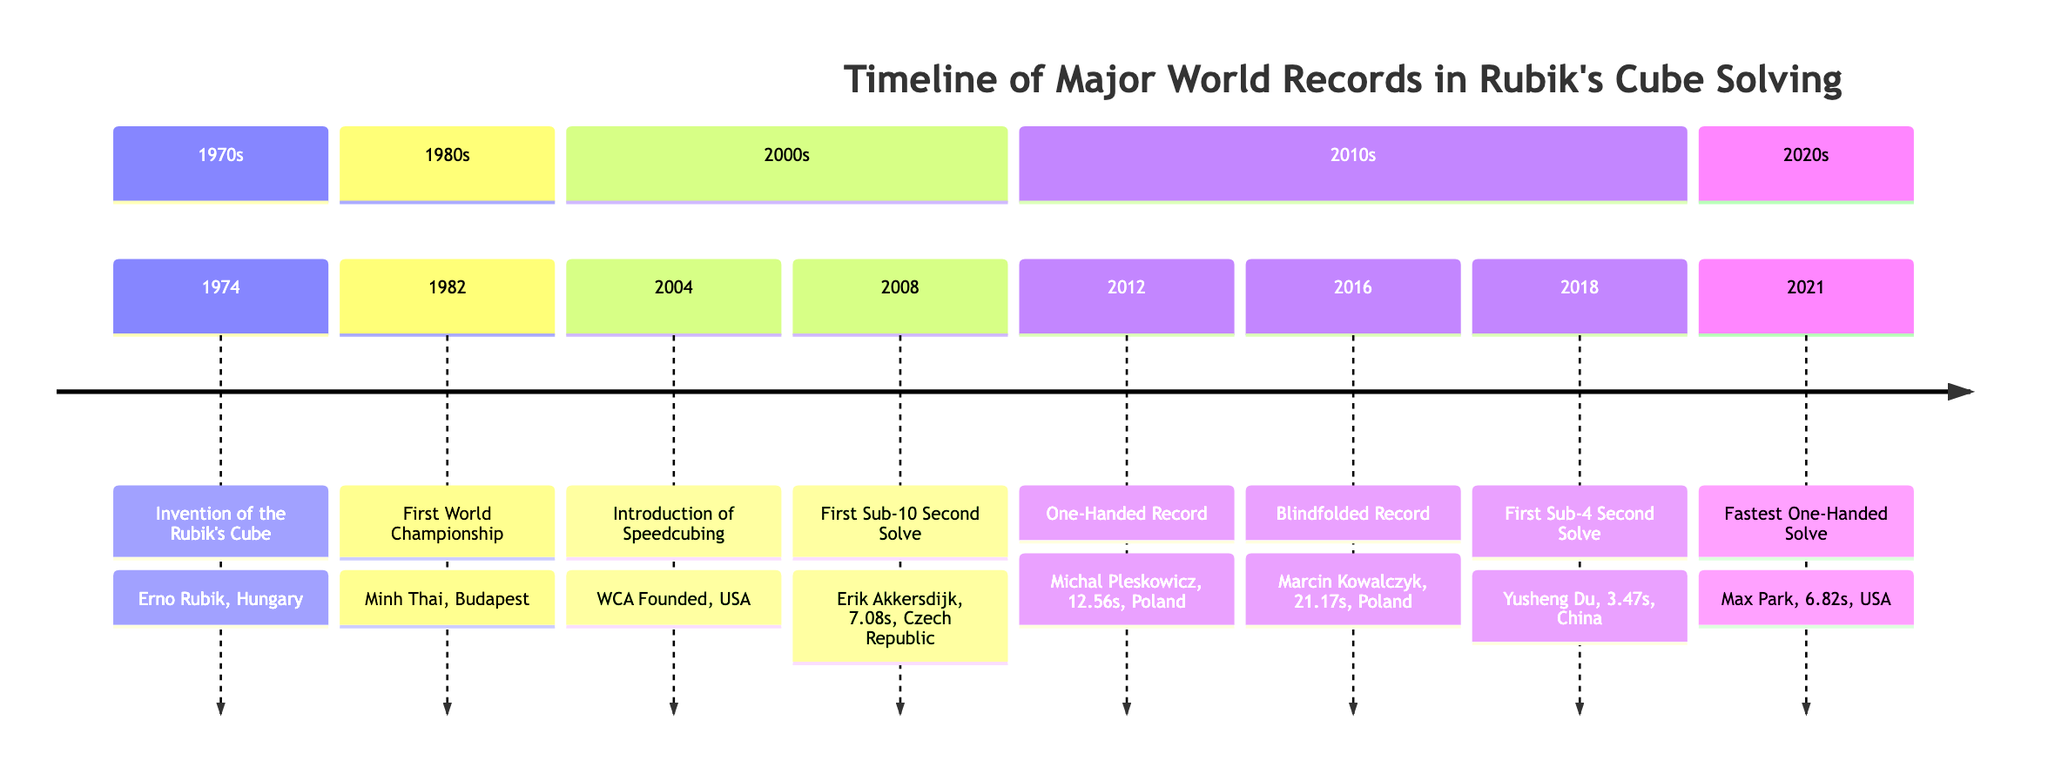What year was the Rubik's Cube invented? The diagram shows that the Rubik's Cube was invented in 1974, as indicated in the 1970s section.
Answer: 1974 Who set the first blindfolded record? Looking at the timeline, the blindfolded record was set by Marcin Kowalczyk in 2016.
Answer: Marcin Kowalczyk What was the fastest one-handed solve time? The fastest one-handed solve time is recorded as 6.82 seconds in 2021 by Max Park.
Answer: 6.82s Which country had the first world champion? The first world champion, Minh Thai, is associated with Hungary as per the information in the 1980s section.
Answer: Hungary How many records are listed for the 2010s? There are three records listed in the 2010s section: one-handed record, blindfolded record, and the first sub-4 second solve.
Answer: 3 Which record was set in 2008? The record from 2008 was the first sub-10 second solve by Erik Akkersdijk, as stated in the 2000s section.
Answer: First Sub-10 Second Solve In which year did the WCA get founded? According to the timeline, the WCA was founded in 2004 in the USA, as mentioned in the 2000s section.
Answer: 2004 What milestone was achieved by Yusheng Du? The diagram indicates that Yusheng Du achieved the first sub-4 second solve in 2018, as shown in the 2010s section.
Answer: First Sub-4 Second Solve Which solve type had its record broken by Max Park? Max Park broke the record for the fastest one-handed solve in 2021, according to the timeline.
Answer: One-Handed 